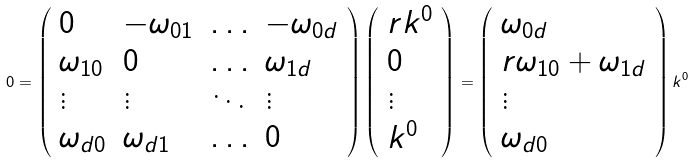<formula> <loc_0><loc_0><loc_500><loc_500>0 = \left ( \begin{array} { l l l l } { 0 } & { { - \omega _ { 0 1 } } } & { \dots } & { { - \omega _ { 0 d } } } \\ { { \omega _ { 1 0 } } } & { 0 } & { \dots } & { { \omega _ { 1 d } } } \\ { \vdots } & { \vdots } & { \ddots } & { \vdots } \\ { { \omega _ { d 0 } } } & { { \omega _ { d 1 } } } & { \dots } & { 0 } \end{array} \right ) \left ( \begin{array} { l } { { r k ^ { 0 } } } \\ { 0 } \\ { \vdots } \\ { { k ^ { 0 } } } \end{array} \right ) = \left ( \begin{array} { l } { { \omega _ { 0 d } } } \\ { { r \omega _ { 1 0 } + \omega _ { 1 d } } } \\ { \vdots } \\ { { \omega _ { d 0 } } } \end{array} \right ) k ^ { 0 }</formula> 